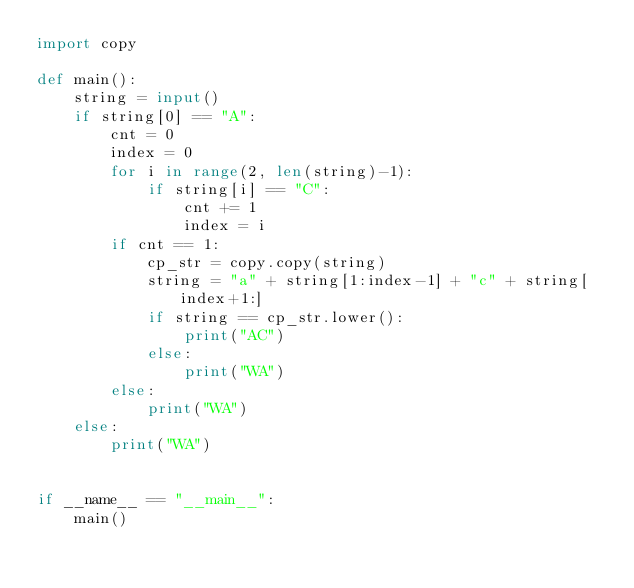Convert code to text. <code><loc_0><loc_0><loc_500><loc_500><_Python_>import copy

def main():
    string = input()
    if string[0] == "A":
        cnt = 0
        index = 0
        for i in range(2, len(string)-1):
            if string[i] == "C":
                cnt += 1
                index = i
        if cnt == 1:
            cp_str = copy.copy(string)
            string = "a" + string[1:index-1] + "c" + string[index+1:]
            if string == cp_str.lower():
                print("AC")
            else:
                print("WA")
        else:
            print("WA")
    else:
        print("WA")


if __name__ == "__main__":
    main()

</code> 